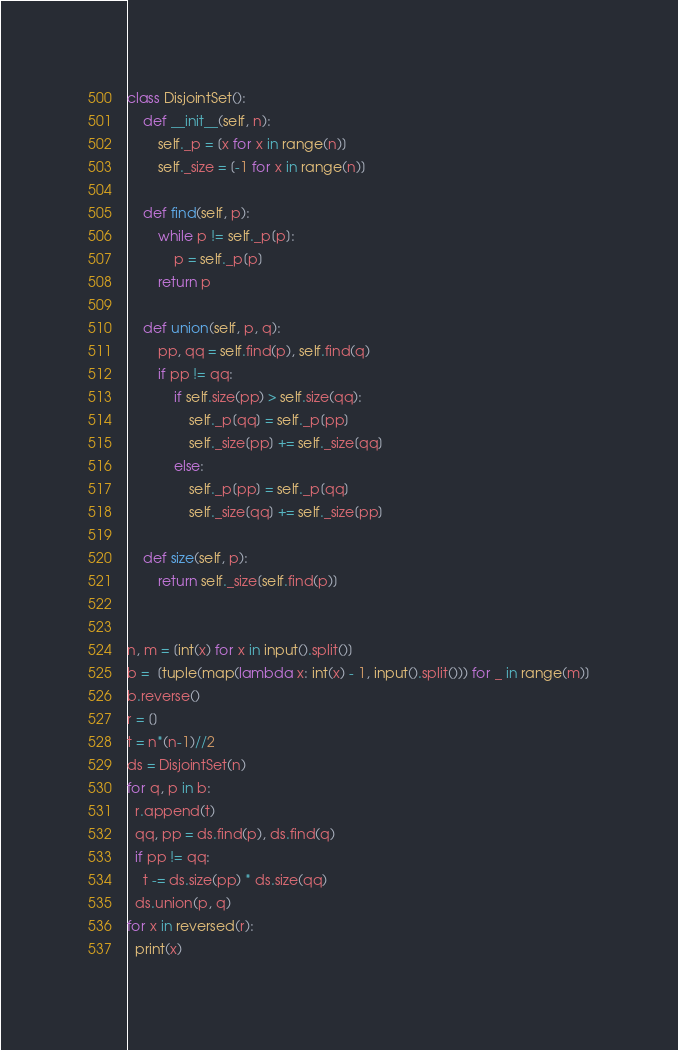Convert code to text. <code><loc_0><loc_0><loc_500><loc_500><_Python_>class DisjointSet():
    def __init__(self, n):
        self._p = [x for x in range(n)]
        self._size = [-1 for x in range(n)]
    
    def find(self, p):
        while p != self._p[p]:
            p = self._p[p]
        return p

    def union(self, p, q):
        pp, qq = self.find(p), self.find(q)
        if pp != qq:
            if self.size(pp) > self.size(qq):
                self._p[qq] = self._p[pp]
                self._size[pp] += self._size[qq]
            else:
                self._p[pp] = self._p[qq]
                self._size[qq] += self._size[pp]
    
    def size(self, p):
        return self._size[self.find(p)]


n, m = [int(x) for x in input().split()]
b =  [tuple(map(lambda x: int(x) - 1, input().split())) for _ in range(m)]
b.reverse()
r = []
t = n*(n-1)//2
ds = DisjointSet(n)
for q, p in b:
  r.append(t)
  qq, pp = ds.find(p), ds.find(q)
  if pp != qq:
    t -= ds.size(pp) * ds.size(qq)
  ds.union(p, q)
for x in reversed(r):
  print(x)</code> 